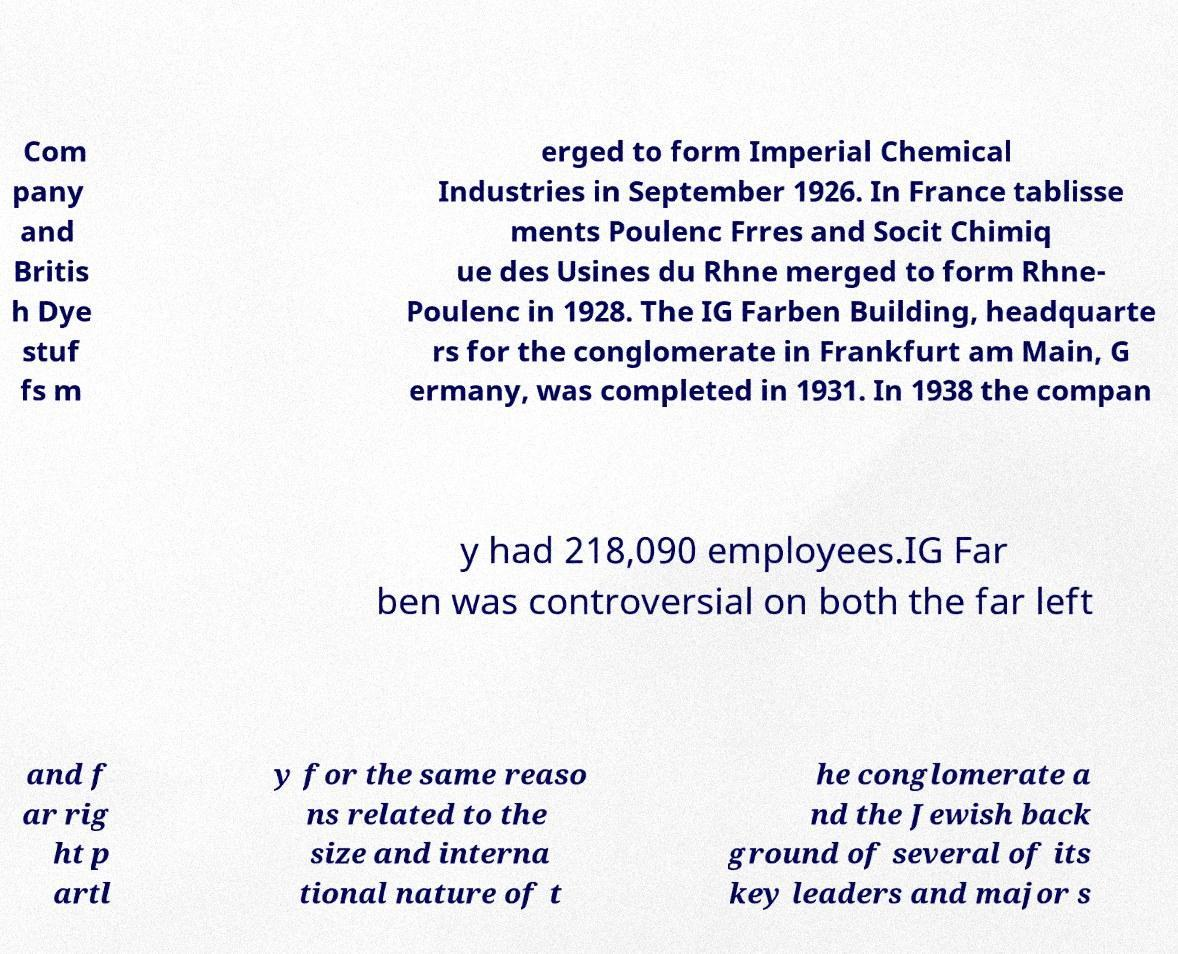Can you accurately transcribe the text from the provided image for me? Com pany and Britis h Dye stuf fs m erged to form Imperial Chemical Industries in September 1926. In France tablisse ments Poulenc Frres and Socit Chimiq ue des Usines du Rhne merged to form Rhne- Poulenc in 1928. The IG Farben Building, headquarte rs for the conglomerate in Frankfurt am Main, G ermany, was completed in 1931. In 1938 the compan y had 218,090 employees.IG Far ben was controversial on both the far left and f ar rig ht p artl y for the same reaso ns related to the size and interna tional nature of t he conglomerate a nd the Jewish back ground of several of its key leaders and major s 